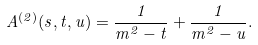<formula> <loc_0><loc_0><loc_500><loc_500>A ^ { ( 2 ) } ( s , t , u ) = \frac { 1 } { m ^ { 2 } - t } + \frac { 1 } { m ^ { 2 } - u } .</formula> 